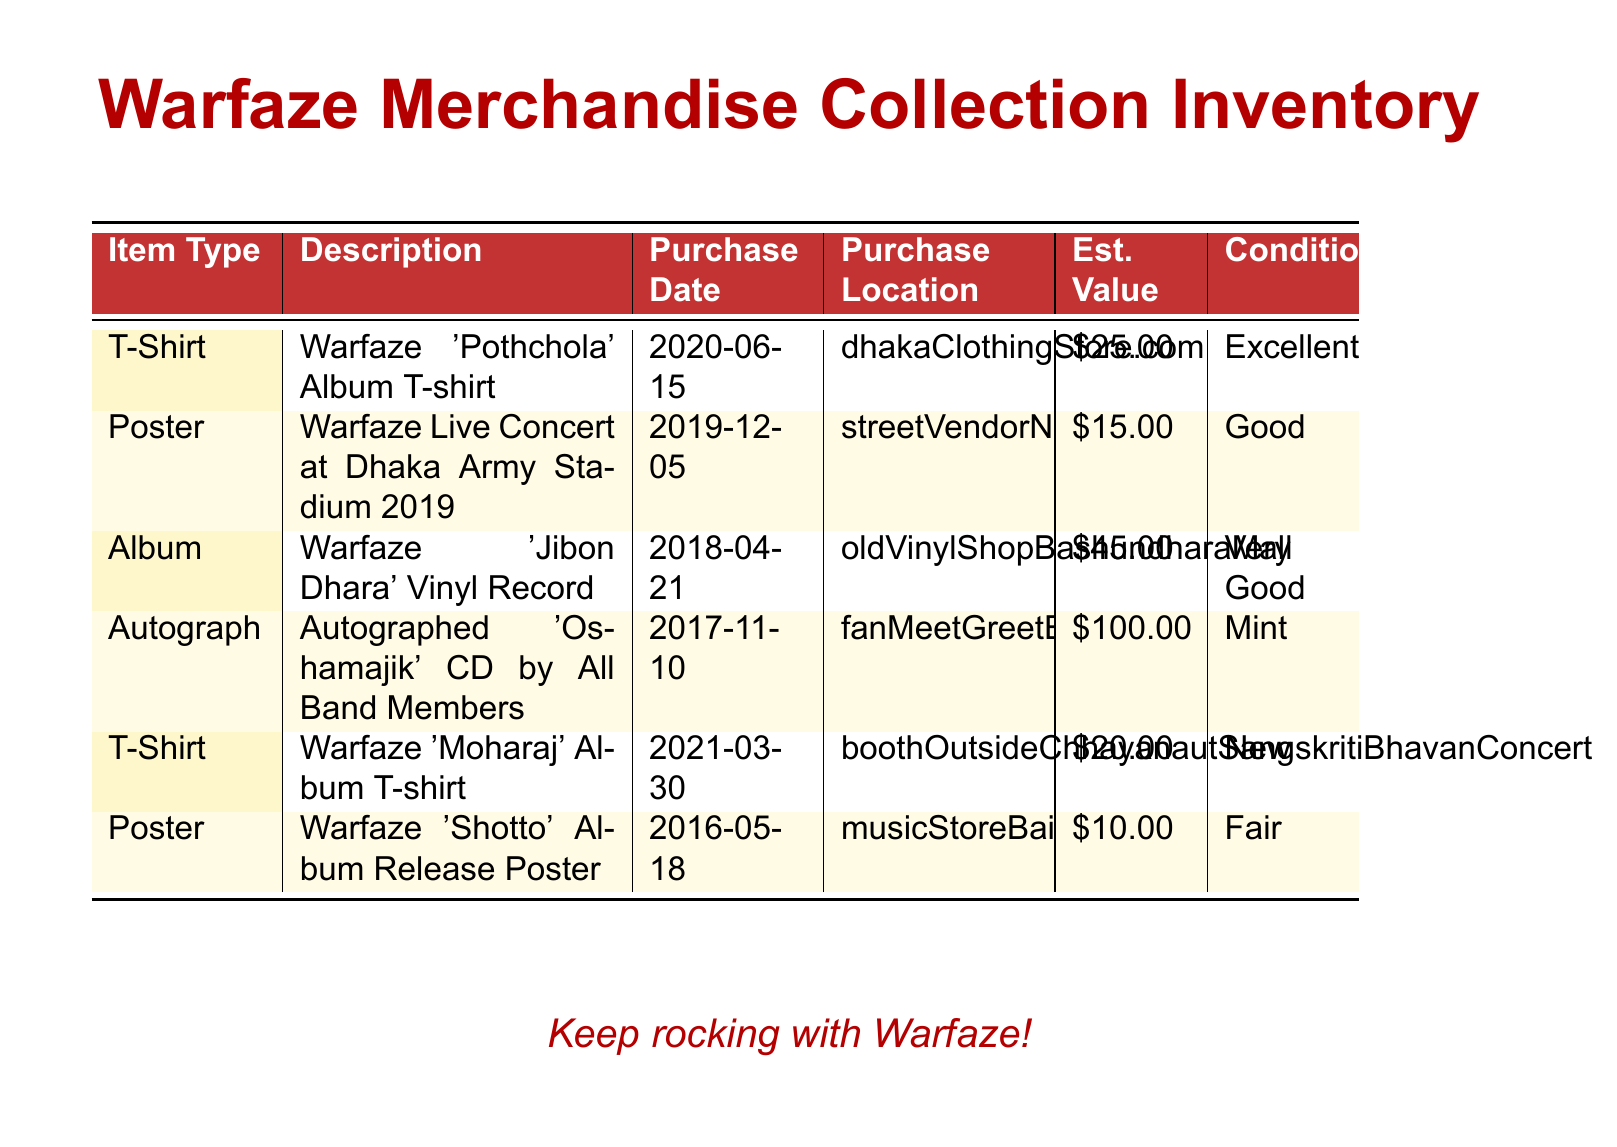What is the first item listed in the inventory? The first item listed is the T-Shirt for the 'Pothchola' Album, making it the initial entry in the table.
Answer: T-Shirt When was the 'Jibon Dhara' Vinyl Record purchased? The purchase date for the 'Jibon Dhara' Vinyl Record is provided in the document, specifically noted as April 21, 2018.
Answer: 2018-04-21 What is the estimated value of the autographed CD? The document states that the estimated value of the autographed 'Oshamajik' CD by all band members is $100.
Answer: $100 Which item has a condition described as 'Fair'? Among the listed items, the 'Shotto' Album Release Poster is noted to be in 'Fair' condition.
Answer: Poster How many T-Shirts are listed in the inventory? By analyzing the table, it is clear that two entries are T-Shirts, indicating a count of 2 for this item type.
Answer: 2 Where was the Warfaze Live Concert poster purchased? The document specifies that the Warfaze Live Concert poster was purchased from a street vendor near Army Stadium.
Answer: streetVendorNearArmyStadium Which item has the highest estimated value? The autographed CD by all band members has the highest estimated value at $100, making it the top-valued item in the inventory.
Answer: Autograph What color scheme is used for the table header? The color scheme for the table header features a deep red background with white text for clarity.
Answer: Red What is the purchase location of the 'Moharaj' Album T-shirt? The purchase location for the 'Moharaj' Album T-shirt is specified as the booth outside the Chhayanaut Sangskriti Bhavan Concert.
Answer: boothOutsideChhayanautSangskritiBhavanConcert 